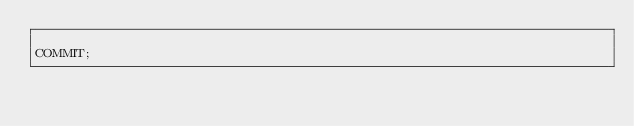Convert code to text. <code><loc_0><loc_0><loc_500><loc_500><_SQL_>
COMMIT;
</code> 